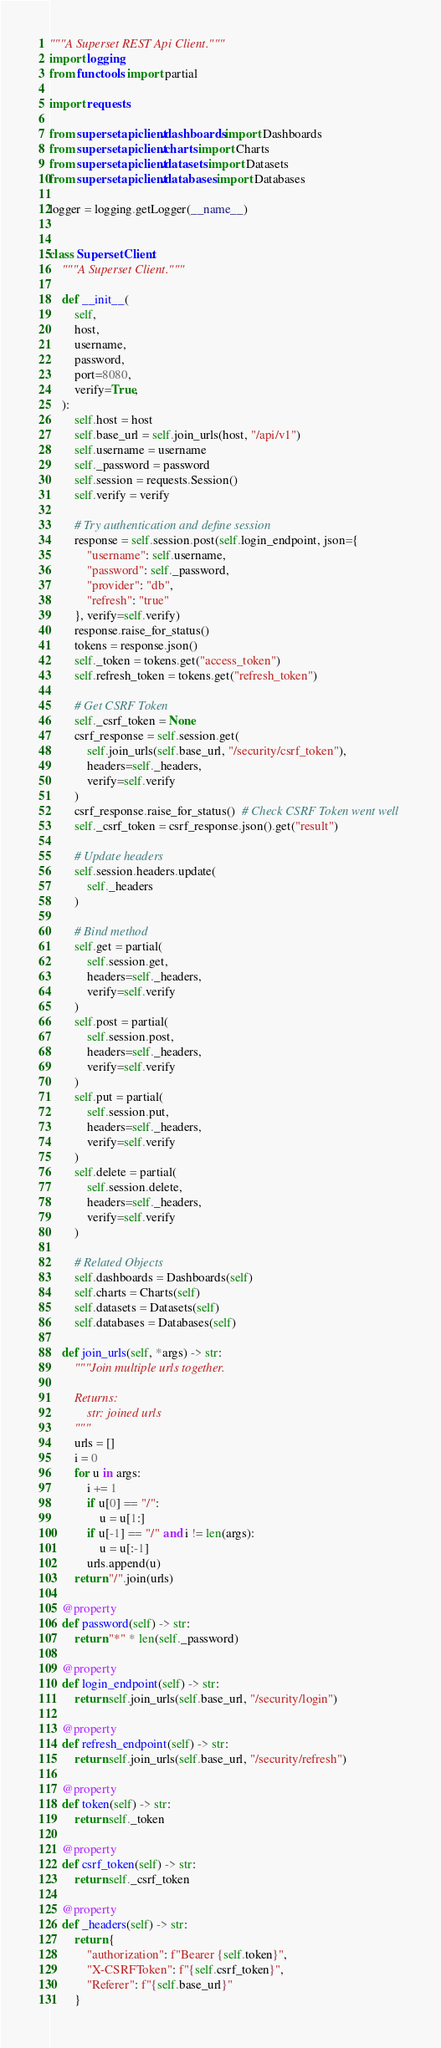<code> <loc_0><loc_0><loc_500><loc_500><_Python_>"""A Superset REST Api Client."""
import logging
from functools import partial

import requests

from supersetapiclient.dashboards import Dashboards
from supersetapiclient.charts import Charts
from supersetapiclient.datasets import Datasets
from supersetapiclient.databases import Databases

logger = logging.getLogger(__name__)


class SupersetClient:
    """A Superset Client."""

    def __init__(
        self,
        host,
        username,
        password,
        port=8080,
        verify=True,
    ):
        self.host = host
        self.base_url = self.join_urls(host, "/api/v1")
        self.username = username
        self._password = password
        self.session = requests.Session()
        self.verify = verify

        # Try authentication and define session
        response = self.session.post(self.login_endpoint, json={
            "username": self.username,
            "password": self._password,
            "provider": "db",
            "refresh": "true"
        }, verify=self.verify)
        response.raise_for_status()
        tokens = response.json()
        self._token = tokens.get("access_token")
        self.refresh_token = tokens.get("refresh_token")

        # Get CSRF Token
        self._csrf_token = None
        csrf_response = self.session.get(
            self.join_urls(self.base_url, "/security/csrf_token"),
            headers=self._headers,
            verify=self.verify
        )
        csrf_response.raise_for_status()  # Check CSRF Token went well
        self._csrf_token = csrf_response.json().get("result")

        # Update headers
        self.session.headers.update(
            self._headers
        )

        # Bind method
        self.get = partial(
            self.session.get,
            headers=self._headers,
            verify=self.verify
        )
        self.post = partial(
            self.session.post,
            headers=self._headers,
            verify=self.verify
        )
        self.put = partial(
            self.session.put,
            headers=self._headers,
            verify=self.verify
        )
        self.delete = partial(
            self.session.delete,
            headers=self._headers,
            verify=self.verify
        )

        # Related Objects
        self.dashboards = Dashboards(self)
        self.charts = Charts(self)
        self.datasets = Datasets(self)
        self.databases = Databases(self)

    def join_urls(self, *args) -> str:
        """Join multiple urls together.

        Returns:
            str: joined urls
        """
        urls = []
        i = 0
        for u in args:
            i += 1
            if u[0] == "/":
                u = u[1:]
            if u[-1] == "/" and i != len(args):
                u = u[:-1]
            urls.append(u)
        return "/".join(urls)

    @property
    def password(self) -> str:
        return "*" * len(self._password)

    @property
    def login_endpoint(self) -> str:
        return self.join_urls(self.base_url, "/security/login")

    @property
    def refresh_endpoint(self) -> str:
        return self.join_urls(self.base_url, "/security/refresh")

    @property
    def token(self) -> str:
        return self._token

    @property
    def csrf_token(self) -> str:
        return self._csrf_token

    @property
    def _headers(self) -> str:
        return {
            "authorization": f"Bearer {self.token}",
            "X-CSRFToken": f"{self.csrf_token}",
            "Referer": f"{self.base_url}"
        }
</code> 